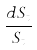Convert formula to latex. <formula><loc_0><loc_0><loc_500><loc_500>\frac { d S _ { t } } { S _ { t } }</formula> 